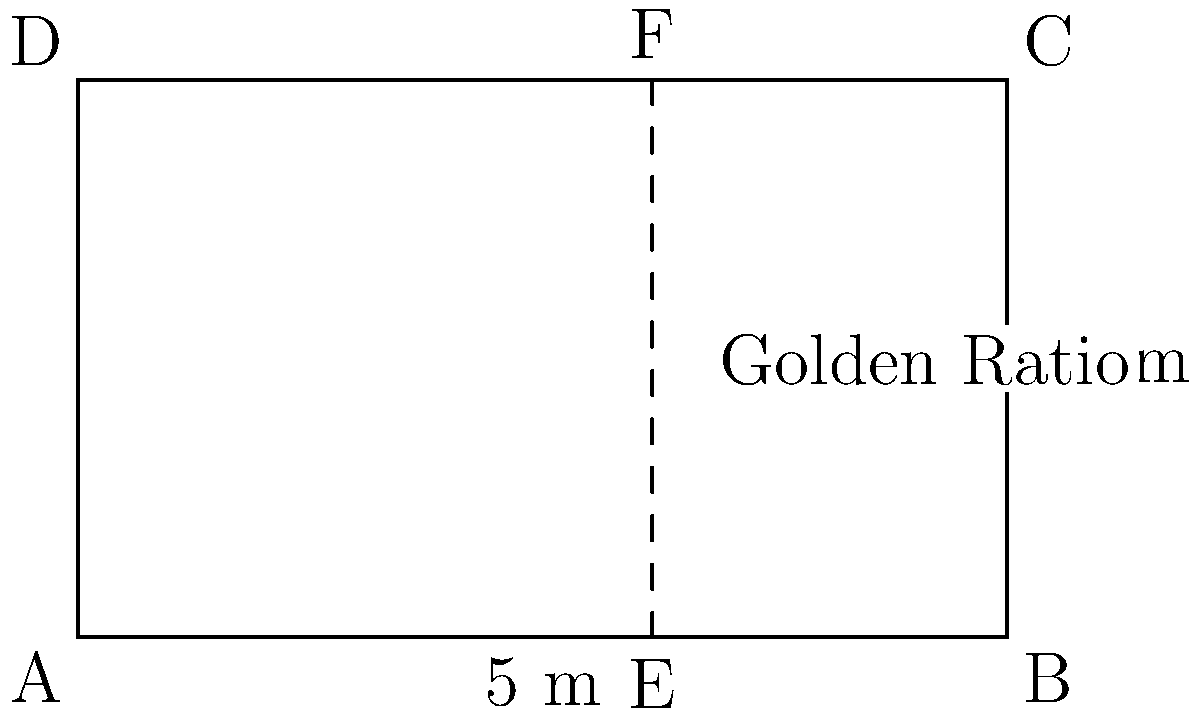St. Mary's Cathedral in Cape Town features a rectangular stained glass window with dimensions of 5 meters wide and 3 meters high. The window is divided vertically according to the golden ratio. If the smaller section of the window's width is represented by $x$, what is the value of $x$ in meters? Let's approach this step-by-step:

1) The golden ratio is defined as $\frac{a+b}{a} = \frac{a}{b} = \phi \approx 1.618$, where $a$ is the larger section and $b$ is the smaller section.

2) In this case, the total width of the window is 5 meters, and we're looking for the smaller section $x$.

3) We can set up the equation:
   $\frac{5}{x} = \phi$

4) We know that $\phi = \frac{1+\sqrt{5}}{2} \approx 1.618$

5) Substituting this value:
   $\frac{5}{x} = \frac{1+\sqrt{5}}{2}$

6) Cross-multiplying:
   $2x = 5(3-\sqrt{5})$

7) Solving for $x$:
   $x = \frac{5(3-\sqrt{5})}{2} \approx 1.91$ meters

8) We can verify: $5 - 1.91 = 3.09$, and $\frac{3.09}{1.91} \approx 1.618$

Therefore, the smaller section of the window is approximately 1.91 meters wide.
Answer: $1.91$ meters 